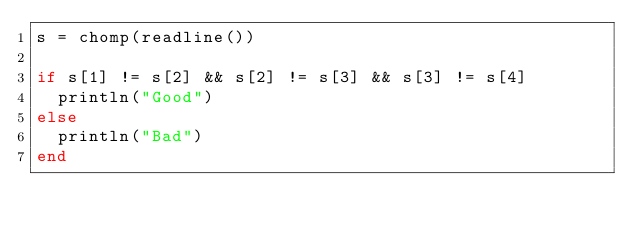Convert code to text. <code><loc_0><loc_0><loc_500><loc_500><_Julia_>s = chomp(readline())

if s[1] != s[2] && s[2] != s[3] && s[3] != s[4]
  println("Good")
else
  println("Bad")
end</code> 